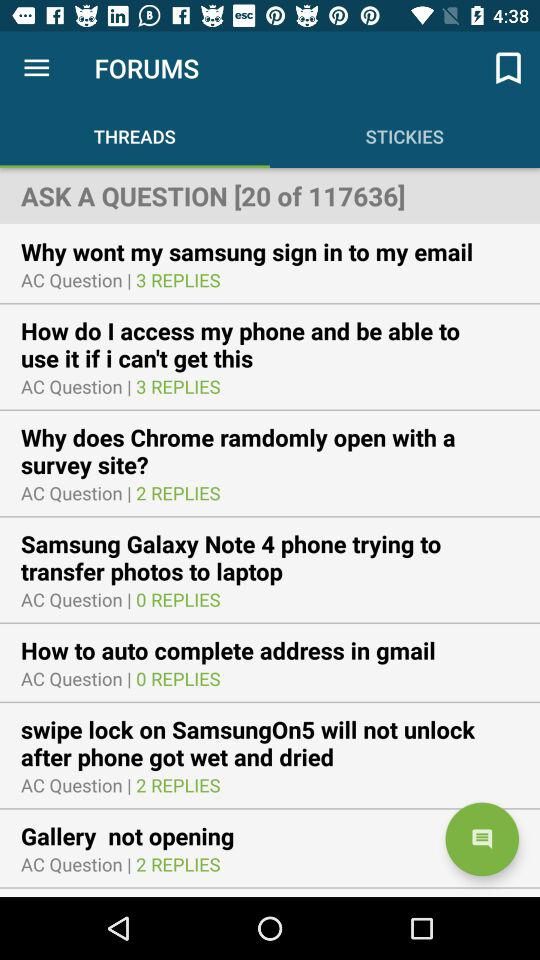Which tab is open? The opened tab is "THREADS". 